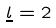<formula> <loc_0><loc_0><loc_500><loc_500>\underline { l } = 2</formula> 